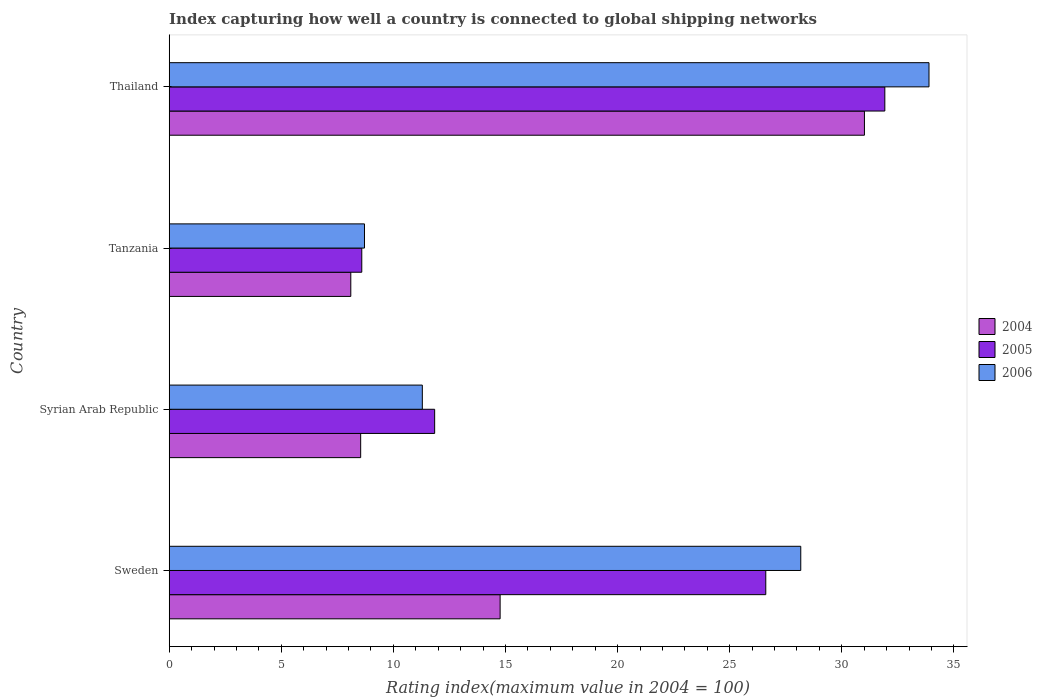How many groups of bars are there?
Provide a short and direct response. 4. Are the number of bars per tick equal to the number of legend labels?
Provide a short and direct response. Yes. Are the number of bars on each tick of the Y-axis equal?
Keep it short and to the point. Yes. How many bars are there on the 2nd tick from the top?
Keep it short and to the point. 3. How many bars are there on the 3rd tick from the bottom?
Provide a succinct answer. 3. In how many cases, is the number of bars for a given country not equal to the number of legend labels?
Offer a terse response. 0. What is the rating index in 2004 in Thailand?
Offer a terse response. 31.01. Across all countries, what is the maximum rating index in 2004?
Offer a terse response. 31.01. Across all countries, what is the minimum rating index in 2005?
Provide a succinct answer. 8.59. In which country was the rating index in 2006 maximum?
Provide a succinct answer. Thailand. In which country was the rating index in 2006 minimum?
Your answer should be very brief. Tanzania. What is the total rating index in 2005 in the graph?
Keep it short and to the point. 78.96. What is the difference between the rating index in 2004 in Thailand and the rating index in 2005 in Syrian Arab Republic?
Your response must be concise. 19.17. What is the average rating index in 2006 per country?
Give a very brief answer. 20.52. What is the difference between the rating index in 2006 and rating index in 2004 in Syrian Arab Republic?
Make the answer very short. 2.75. What is the ratio of the rating index in 2006 in Sweden to that in Tanzania?
Give a very brief answer. 3.23. Is the rating index in 2004 in Syrian Arab Republic less than that in Tanzania?
Give a very brief answer. No. Is the difference between the rating index in 2006 in Sweden and Tanzania greater than the difference between the rating index in 2004 in Sweden and Tanzania?
Offer a very short reply. Yes. What is the difference between the highest and the second highest rating index in 2004?
Your response must be concise. 16.25. What is the difference between the highest and the lowest rating index in 2005?
Your answer should be very brief. 23.33. Is the sum of the rating index in 2005 in Sweden and Syrian Arab Republic greater than the maximum rating index in 2006 across all countries?
Provide a succinct answer. Yes. How many bars are there?
Your answer should be compact. 12. Are all the bars in the graph horizontal?
Keep it short and to the point. Yes. What is the difference between two consecutive major ticks on the X-axis?
Your answer should be compact. 5. Does the graph contain any zero values?
Ensure brevity in your answer.  No. Does the graph contain grids?
Your response must be concise. No. What is the title of the graph?
Offer a very short reply. Index capturing how well a country is connected to global shipping networks. Does "1967" appear as one of the legend labels in the graph?
Your answer should be very brief. No. What is the label or title of the X-axis?
Offer a very short reply. Rating index(maximum value in 2004 = 100). What is the Rating index(maximum value in 2004 = 100) in 2004 in Sweden?
Your answer should be compact. 14.76. What is the Rating index(maximum value in 2004 = 100) of 2005 in Sweden?
Provide a short and direct response. 26.61. What is the Rating index(maximum value in 2004 = 100) of 2006 in Sweden?
Your response must be concise. 28.17. What is the Rating index(maximum value in 2004 = 100) in 2004 in Syrian Arab Republic?
Ensure brevity in your answer.  8.54. What is the Rating index(maximum value in 2004 = 100) of 2005 in Syrian Arab Republic?
Provide a succinct answer. 11.84. What is the Rating index(maximum value in 2004 = 100) of 2006 in Syrian Arab Republic?
Keep it short and to the point. 11.29. What is the Rating index(maximum value in 2004 = 100) of 2004 in Tanzania?
Your answer should be very brief. 8.1. What is the Rating index(maximum value in 2004 = 100) in 2005 in Tanzania?
Provide a succinct answer. 8.59. What is the Rating index(maximum value in 2004 = 100) in 2006 in Tanzania?
Provide a short and direct response. 8.71. What is the Rating index(maximum value in 2004 = 100) in 2004 in Thailand?
Ensure brevity in your answer.  31.01. What is the Rating index(maximum value in 2004 = 100) in 2005 in Thailand?
Your answer should be very brief. 31.92. What is the Rating index(maximum value in 2004 = 100) of 2006 in Thailand?
Give a very brief answer. 33.89. Across all countries, what is the maximum Rating index(maximum value in 2004 = 100) of 2004?
Give a very brief answer. 31.01. Across all countries, what is the maximum Rating index(maximum value in 2004 = 100) in 2005?
Give a very brief answer. 31.92. Across all countries, what is the maximum Rating index(maximum value in 2004 = 100) in 2006?
Ensure brevity in your answer.  33.89. Across all countries, what is the minimum Rating index(maximum value in 2004 = 100) of 2005?
Ensure brevity in your answer.  8.59. Across all countries, what is the minimum Rating index(maximum value in 2004 = 100) of 2006?
Provide a short and direct response. 8.71. What is the total Rating index(maximum value in 2004 = 100) of 2004 in the graph?
Make the answer very short. 62.41. What is the total Rating index(maximum value in 2004 = 100) of 2005 in the graph?
Ensure brevity in your answer.  78.96. What is the total Rating index(maximum value in 2004 = 100) of 2006 in the graph?
Offer a terse response. 82.06. What is the difference between the Rating index(maximum value in 2004 = 100) in 2004 in Sweden and that in Syrian Arab Republic?
Make the answer very short. 6.22. What is the difference between the Rating index(maximum value in 2004 = 100) in 2005 in Sweden and that in Syrian Arab Republic?
Make the answer very short. 14.77. What is the difference between the Rating index(maximum value in 2004 = 100) of 2006 in Sweden and that in Syrian Arab Republic?
Offer a terse response. 16.88. What is the difference between the Rating index(maximum value in 2004 = 100) in 2004 in Sweden and that in Tanzania?
Offer a very short reply. 6.66. What is the difference between the Rating index(maximum value in 2004 = 100) of 2005 in Sweden and that in Tanzania?
Your answer should be very brief. 18.02. What is the difference between the Rating index(maximum value in 2004 = 100) of 2006 in Sweden and that in Tanzania?
Offer a very short reply. 19.46. What is the difference between the Rating index(maximum value in 2004 = 100) in 2004 in Sweden and that in Thailand?
Provide a succinct answer. -16.25. What is the difference between the Rating index(maximum value in 2004 = 100) in 2005 in Sweden and that in Thailand?
Your answer should be very brief. -5.31. What is the difference between the Rating index(maximum value in 2004 = 100) in 2006 in Sweden and that in Thailand?
Provide a succinct answer. -5.72. What is the difference between the Rating index(maximum value in 2004 = 100) in 2004 in Syrian Arab Republic and that in Tanzania?
Your answer should be very brief. 0.44. What is the difference between the Rating index(maximum value in 2004 = 100) in 2005 in Syrian Arab Republic and that in Tanzania?
Provide a succinct answer. 3.25. What is the difference between the Rating index(maximum value in 2004 = 100) in 2006 in Syrian Arab Republic and that in Tanzania?
Provide a short and direct response. 2.58. What is the difference between the Rating index(maximum value in 2004 = 100) of 2004 in Syrian Arab Republic and that in Thailand?
Make the answer very short. -22.47. What is the difference between the Rating index(maximum value in 2004 = 100) in 2005 in Syrian Arab Republic and that in Thailand?
Your answer should be very brief. -20.08. What is the difference between the Rating index(maximum value in 2004 = 100) in 2006 in Syrian Arab Republic and that in Thailand?
Your answer should be very brief. -22.6. What is the difference between the Rating index(maximum value in 2004 = 100) in 2004 in Tanzania and that in Thailand?
Provide a succinct answer. -22.91. What is the difference between the Rating index(maximum value in 2004 = 100) of 2005 in Tanzania and that in Thailand?
Provide a succinct answer. -23.33. What is the difference between the Rating index(maximum value in 2004 = 100) in 2006 in Tanzania and that in Thailand?
Ensure brevity in your answer.  -25.18. What is the difference between the Rating index(maximum value in 2004 = 100) in 2004 in Sweden and the Rating index(maximum value in 2004 = 100) in 2005 in Syrian Arab Republic?
Your response must be concise. 2.92. What is the difference between the Rating index(maximum value in 2004 = 100) in 2004 in Sweden and the Rating index(maximum value in 2004 = 100) in 2006 in Syrian Arab Republic?
Offer a terse response. 3.47. What is the difference between the Rating index(maximum value in 2004 = 100) of 2005 in Sweden and the Rating index(maximum value in 2004 = 100) of 2006 in Syrian Arab Republic?
Your answer should be compact. 15.32. What is the difference between the Rating index(maximum value in 2004 = 100) in 2004 in Sweden and the Rating index(maximum value in 2004 = 100) in 2005 in Tanzania?
Your response must be concise. 6.17. What is the difference between the Rating index(maximum value in 2004 = 100) of 2004 in Sweden and the Rating index(maximum value in 2004 = 100) of 2006 in Tanzania?
Provide a succinct answer. 6.05. What is the difference between the Rating index(maximum value in 2004 = 100) in 2005 in Sweden and the Rating index(maximum value in 2004 = 100) in 2006 in Tanzania?
Provide a short and direct response. 17.9. What is the difference between the Rating index(maximum value in 2004 = 100) of 2004 in Sweden and the Rating index(maximum value in 2004 = 100) of 2005 in Thailand?
Your answer should be compact. -17.16. What is the difference between the Rating index(maximum value in 2004 = 100) in 2004 in Sweden and the Rating index(maximum value in 2004 = 100) in 2006 in Thailand?
Ensure brevity in your answer.  -19.13. What is the difference between the Rating index(maximum value in 2004 = 100) in 2005 in Sweden and the Rating index(maximum value in 2004 = 100) in 2006 in Thailand?
Provide a succinct answer. -7.28. What is the difference between the Rating index(maximum value in 2004 = 100) in 2004 in Syrian Arab Republic and the Rating index(maximum value in 2004 = 100) in 2006 in Tanzania?
Provide a succinct answer. -0.17. What is the difference between the Rating index(maximum value in 2004 = 100) of 2005 in Syrian Arab Republic and the Rating index(maximum value in 2004 = 100) of 2006 in Tanzania?
Offer a terse response. 3.13. What is the difference between the Rating index(maximum value in 2004 = 100) of 2004 in Syrian Arab Republic and the Rating index(maximum value in 2004 = 100) of 2005 in Thailand?
Offer a very short reply. -23.38. What is the difference between the Rating index(maximum value in 2004 = 100) of 2004 in Syrian Arab Republic and the Rating index(maximum value in 2004 = 100) of 2006 in Thailand?
Your answer should be compact. -25.35. What is the difference between the Rating index(maximum value in 2004 = 100) of 2005 in Syrian Arab Republic and the Rating index(maximum value in 2004 = 100) of 2006 in Thailand?
Give a very brief answer. -22.05. What is the difference between the Rating index(maximum value in 2004 = 100) of 2004 in Tanzania and the Rating index(maximum value in 2004 = 100) of 2005 in Thailand?
Your response must be concise. -23.82. What is the difference between the Rating index(maximum value in 2004 = 100) of 2004 in Tanzania and the Rating index(maximum value in 2004 = 100) of 2006 in Thailand?
Your answer should be compact. -25.79. What is the difference between the Rating index(maximum value in 2004 = 100) of 2005 in Tanzania and the Rating index(maximum value in 2004 = 100) of 2006 in Thailand?
Your answer should be compact. -25.3. What is the average Rating index(maximum value in 2004 = 100) in 2004 per country?
Keep it short and to the point. 15.6. What is the average Rating index(maximum value in 2004 = 100) in 2005 per country?
Your response must be concise. 19.74. What is the average Rating index(maximum value in 2004 = 100) of 2006 per country?
Your answer should be compact. 20.52. What is the difference between the Rating index(maximum value in 2004 = 100) of 2004 and Rating index(maximum value in 2004 = 100) of 2005 in Sweden?
Your answer should be compact. -11.85. What is the difference between the Rating index(maximum value in 2004 = 100) in 2004 and Rating index(maximum value in 2004 = 100) in 2006 in Sweden?
Keep it short and to the point. -13.41. What is the difference between the Rating index(maximum value in 2004 = 100) of 2005 and Rating index(maximum value in 2004 = 100) of 2006 in Sweden?
Offer a very short reply. -1.56. What is the difference between the Rating index(maximum value in 2004 = 100) in 2004 and Rating index(maximum value in 2004 = 100) in 2006 in Syrian Arab Republic?
Keep it short and to the point. -2.75. What is the difference between the Rating index(maximum value in 2004 = 100) of 2005 and Rating index(maximum value in 2004 = 100) of 2006 in Syrian Arab Republic?
Your answer should be compact. 0.55. What is the difference between the Rating index(maximum value in 2004 = 100) of 2004 and Rating index(maximum value in 2004 = 100) of 2005 in Tanzania?
Keep it short and to the point. -0.49. What is the difference between the Rating index(maximum value in 2004 = 100) of 2004 and Rating index(maximum value in 2004 = 100) of 2006 in Tanzania?
Your answer should be compact. -0.61. What is the difference between the Rating index(maximum value in 2004 = 100) of 2005 and Rating index(maximum value in 2004 = 100) of 2006 in Tanzania?
Provide a succinct answer. -0.12. What is the difference between the Rating index(maximum value in 2004 = 100) of 2004 and Rating index(maximum value in 2004 = 100) of 2005 in Thailand?
Provide a succinct answer. -0.91. What is the difference between the Rating index(maximum value in 2004 = 100) of 2004 and Rating index(maximum value in 2004 = 100) of 2006 in Thailand?
Your answer should be compact. -2.88. What is the difference between the Rating index(maximum value in 2004 = 100) in 2005 and Rating index(maximum value in 2004 = 100) in 2006 in Thailand?
Your response must be concise. -1.97. What is the ratio of the Rating index(maximum value in 2004 = 100) of 2004 in Sweden to that in Syrian Arab Republic?
Give a very brief answer. 1.73. What is the ratio of the Rating index(maximum value in 2004 = 100) of 2005 in Sweden to that in Syrian Arab Republic?
Give a very brief answer. 2.25. What is the ratio of the Rating index(maximum value in 2004 = 100) in 2006 in Sweden to that in Syrian Arab Republic?
Make the answer very short. 2.5. What is the ratio of the Rating index(maximum value in 2004 = 100) of 2004 in Sweden to that in Tanzania?
Keep it short and to the point. 1.82. What is the ratio of the Rating index(maximum value in 2004 = 100) of 2005 in Sweden to that in Tanzania?
Your answer should be very brief. 3.1. What is the ratio of the Rating index(maximum value in 2004 = 100) in 2006 in Sweden to that in Tanzania?
Your answer should be very brief. 3.23. What is the ratio of the Rating index(maximum value in 2004 = 100) in 2004 in Sweden to that in Thailand?
Make the answer very short. 0.48. What is the ratio of the Rating index(maximum value in 2004 = 100) of 2005 in Sweden to that in Thailand?
Provide a succinct answer. 0.83. What is the ratio of the Rating index(maximum value in 2004 = 100) in 2006 in Sweden to that in Thailand?
Your answer should be compact. 0.83. What is the ratio of the Rating index(maximum value in 2004 = 100) of 2004 in Syrian Arab Republic to that in Tanzania?
Your answer should be compact. 1.05. What is the ratio of the Rating index(maximum value in 2004 = 100) of 2005 in Syrian Arab Republic to that in Tanzania?
Make the answer very short. 1.38. What is the ratio of the Rating index(maximum value in 2004 = 100) of 2006 in Syrian Arab Republic to that in Tanzania?
Keep it short and to the point. 1.3. What is the ratio of the Rating index(maximum value in 2004 = 100) in 2004 in Syrian Arab Republic to that in Thailand?
Your response must be concise. 0.28. What is the ratio of the Rating index(maximum value in 2004 = 100) of 2005 in Syrian Arab Republic to that in Thailand?
Keep it short and to the point. 0.37. What is the ratio of the Rating index(maximum value in 2004 = 100) of 2006 in Syrian Arab Republic to that in Thailand?
Give a very brief answer. 0.33. What is the ratio of the Rating index(maximum value in 2004 = 100) in 2004 in Tanzania to that in Thailand?
Your answer should be compact. 0.26. What is the ratio of the Rating index(maximum value in 2004 = 100) of 2005 in Tanzania to that in Thailand?
Your answer should be very brief. 0.27. What is the ratio of the Rating index(maximum value in 2004 = 100) of 2006 in Tanzania to that in Thailand?
Offer a terse response. 0.26. What is the difference between the highest and the second highest Rating index(maximum value in 2004 = 100) of 2004?
Provide a short and direct response. 16.25. What is the difference between the highest and the second highest Rating index(maximum value in 2004 = 100) in 2005?
Offer a terse response. 5.31. What is the difference between the highest and the second highest Rating index(maximum value in 2004 = 100) of 2006?
Provide a succinct answer. 5.72. What is the difference between the highest and the lowest Rating index(maximum value in 2004 = 100) in 2004?
Offer a very short reply. 22.91. What is the difference between the highest and the lowest Rating index(maximum value in 2004 = 100) in 2005?
Give a very brief answer. 23.33. What is the difference between the highest and the lowest Rating index(maximum value in 2004 = 100) of 2006?
Your answer should be very brief. 25.18. 